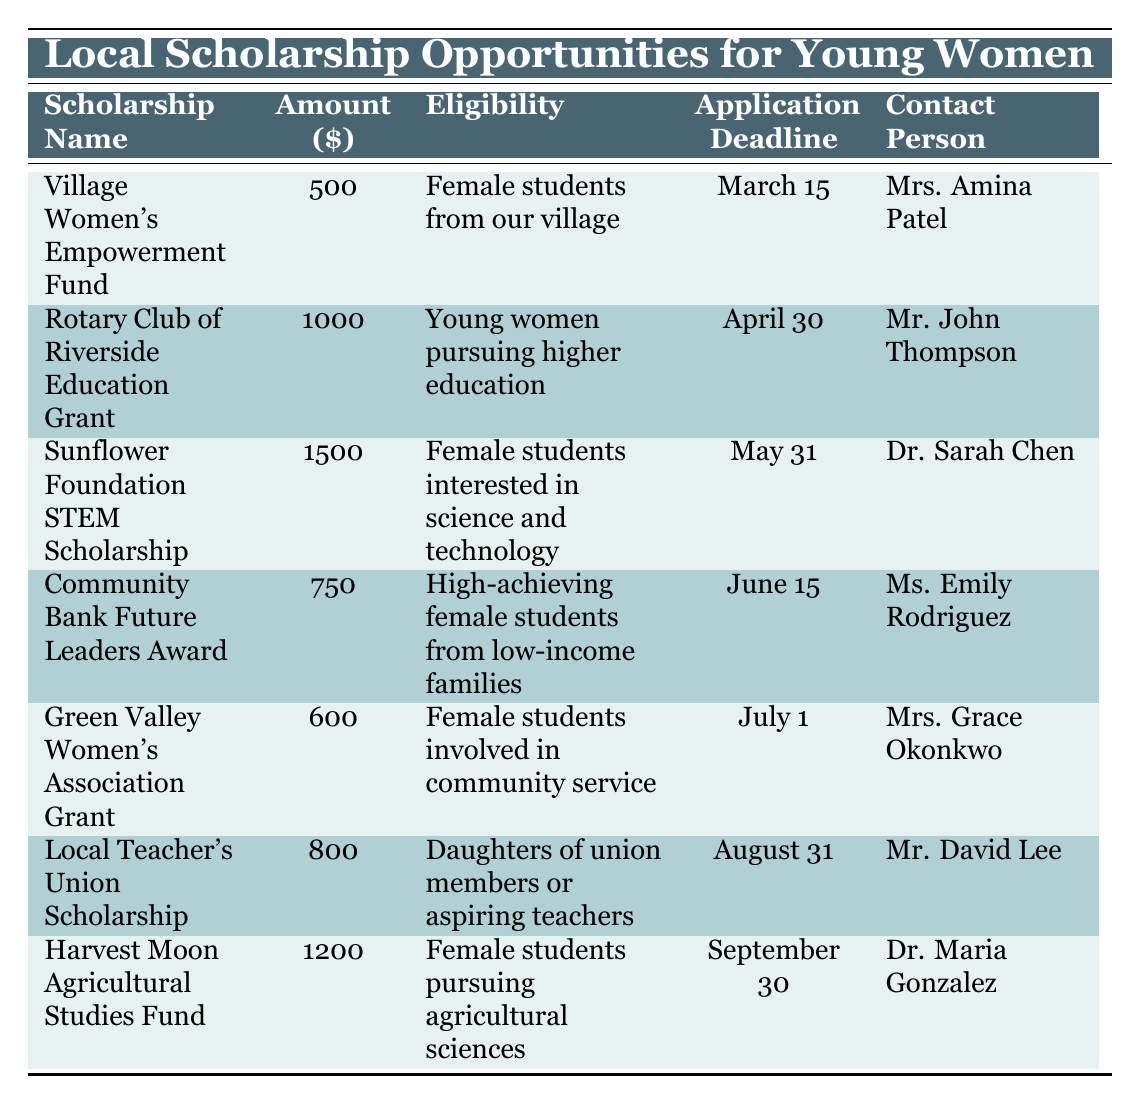What is the amount of the Village Women's Empowerment Fund? The scholarship name is "Village Women's Empowerment Fund," and its corresponding amount is listed under the Amount column as 500.
Answer: 500 Which scholarship has the highest amount? Looking through the amounts listed in the table, "Sunflower Foundation STEM Scholarship" has an amount of 1500, which is greater than all other scholarships.
Answer: Sunflower Foundation STEM Scholarship Is the Rotary Club of Riverside Education Grant available for high-achieving female students from low-income families? The eligibility for the "Rotary Club of Riverside Education Grant" is specifically noted as "Young women pursuing higher education," which does not match the criteria for high-achieving students from low-income families.
Answer: No How many scholarships have application deadlines before June? The application deadlines before June are for "Village Women's Empowerment Fund" (March 15), "Rotary Club of Riverside Education Grant" (April 30), and "Sunflower Foundation STEM Scholarship" (May 31). Counting these reveals there are three scholarships.
Answer: 3 What is the average scholarship amount for all listed opportunities? To find the average, we sum all scholarship amounts: (500 + 1000 + 1500 + 750 + 600 + 800 + 1200) = 4350. There are 7 scholarships, so the average amount is 4350/7 = 621.43, which can be rounded to 621 when considering only whole dollars.
Answer: 621 Which scholarships have application deadlines after August 1? The applicable scholarships with deadlines after August 1 are "Harvest Moon Agricultural Studies Fund," which has a deadline of September 30, and does not include any scholarships with deadlines before that date.
Answer: 1 Is the amount for the Green Valley Women's Association Grant greater than 700? The amount listed for "Green Valley Women's Association Grant" is 600, which is less than 700, therefore, the answer is negative.
Answer: No Which contact person is associated with the Local Teacher's Union Scholarship? The contact person for the "Local Teacher's Union Scholarship" is listed as "Mr. David Lee," as seen in the Contact Person column.
Answer: Mr. David Lee 